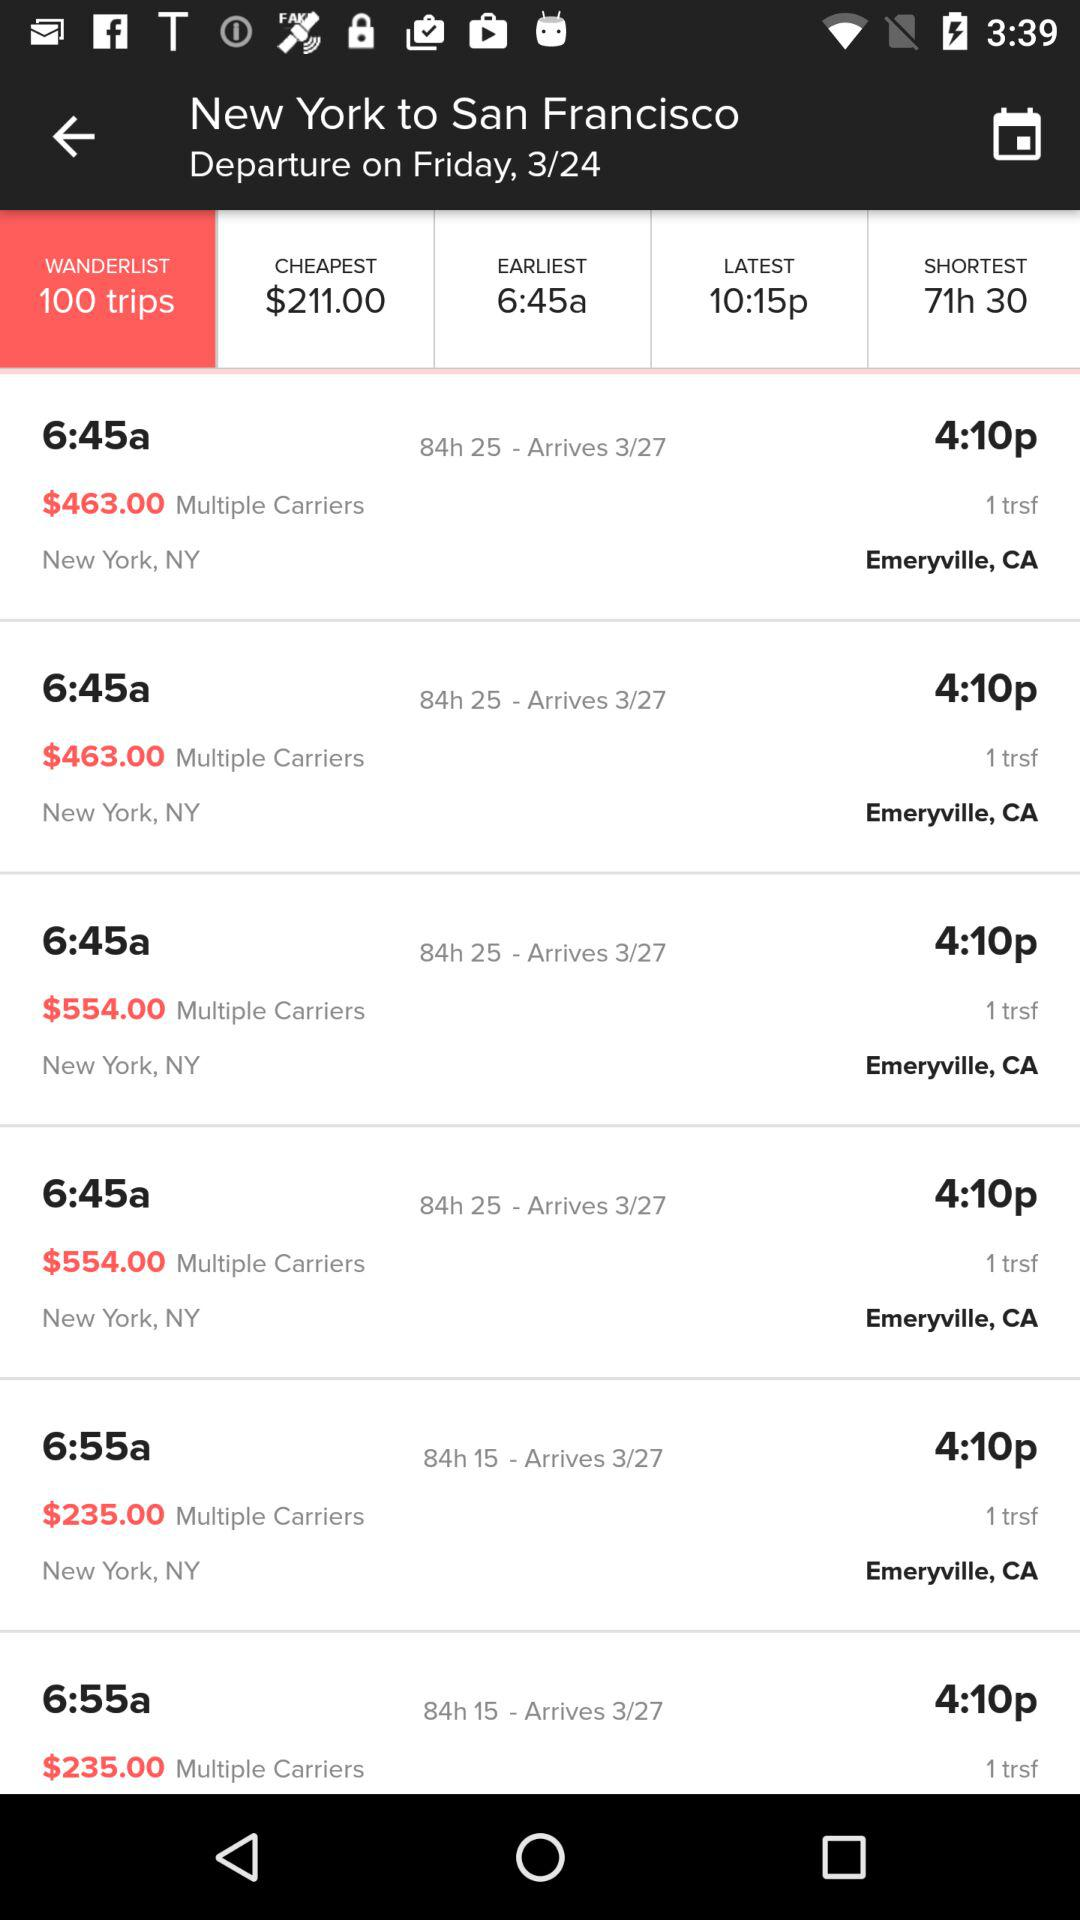What is the number of trips in the "WANDERLIST" segment? The number of trips in the "WANDERLIST" segment is 100. 